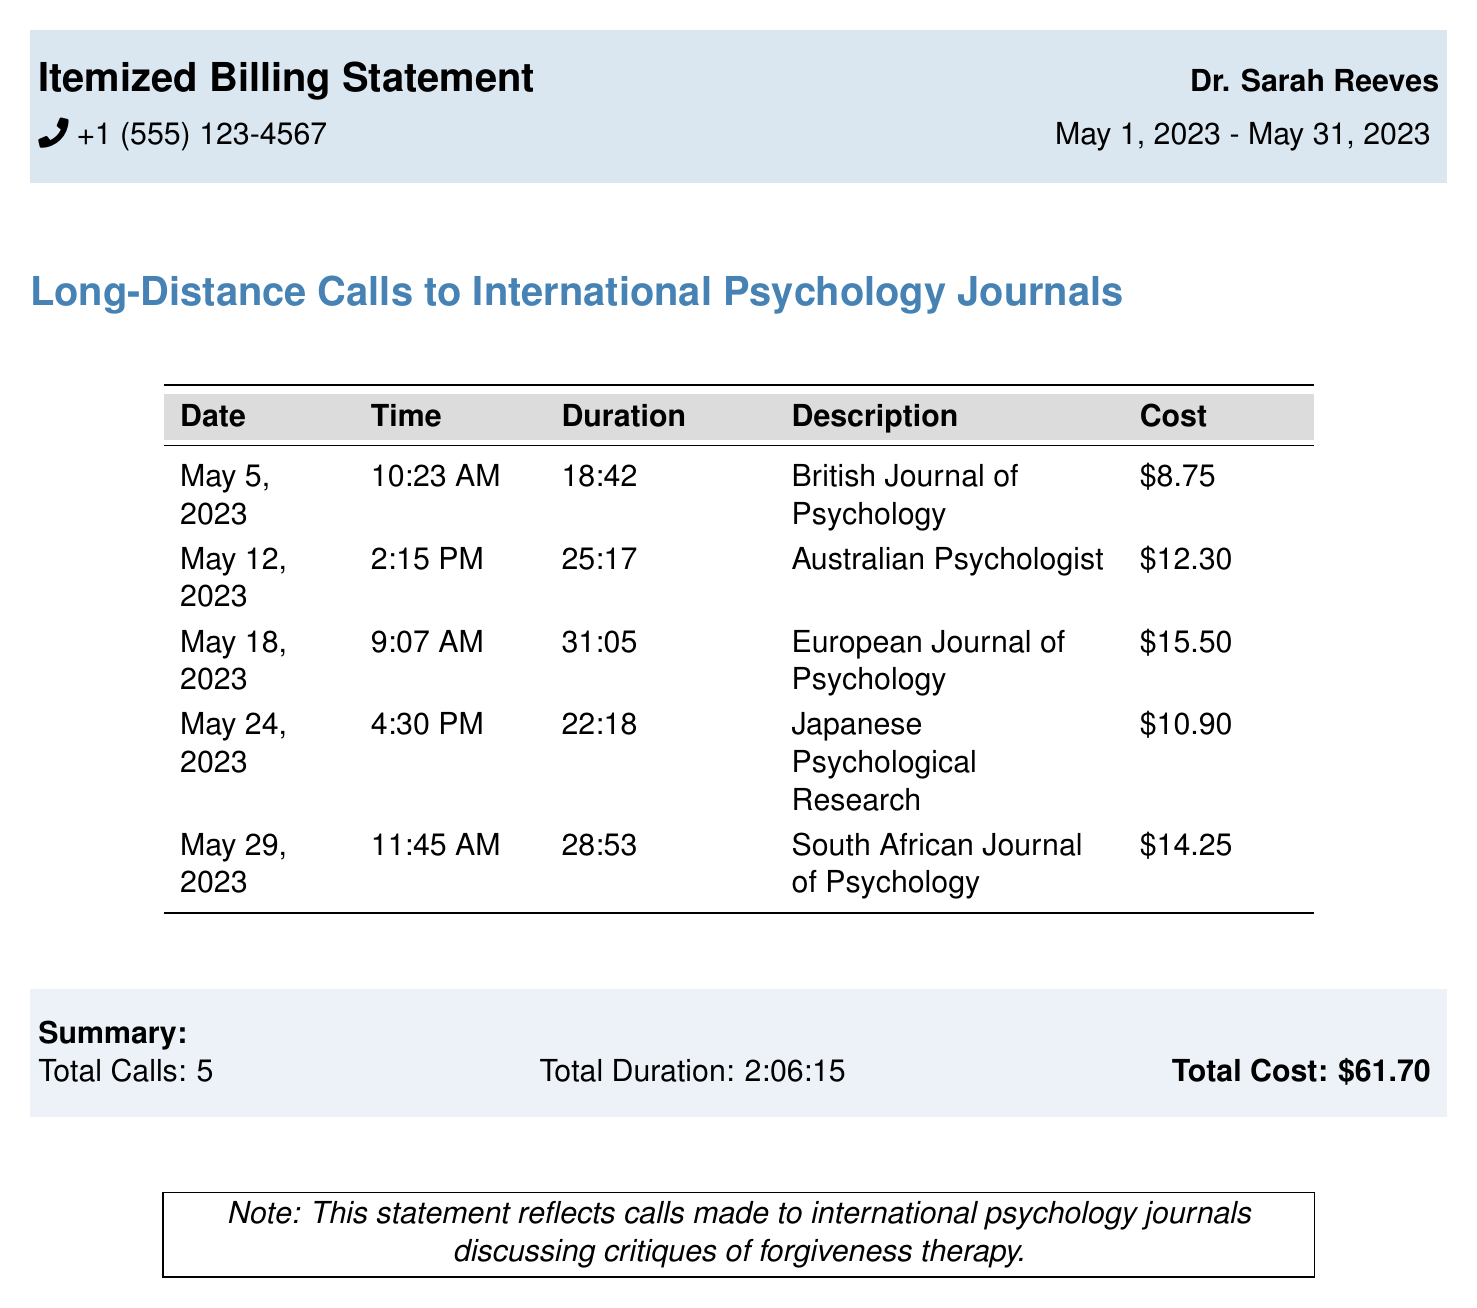what is the total cost of the calls? The total cost is a summary value at the end of the document, calculated by summing all individual call costs, which is $8.75 + $12.30 + $15.50 + $10.90 + $14.25.
Answer: $61.70 how many total calls were made? The total number of calls is specified in the summary section of the document.
Answer: 5 what was the duration of the longest call? The duration of the longest call can be found in the table; the call to the European Journal of Psychology has the longest duration of 31 minutes and 5 seconds.
Answer: 31:05 which journal was called on May 12, 2023? The journal called on this date is noted in the respective row of the table.
Answer: Australian Psychologist what was the cost of the call to the South African Journal of Psychology? The cost is listed in the table under the respective call entry.
Answer: $14.25 what is the time of the call made to the British Journal of Psychology? The time is explicitly mentioned in the same row as the call entry in the table.
Answer: 10:23 AM how much time was spent on the calls in total? The total duration is provided in the summary section, which adds up all individual call times.
Answer: 2:06:15 which call had the second highest cost? To determine this, one would compare the costs of all calls listed in the table.
Answer: Australian Psychologist what is the purpose of the calls made in this statement? The purpose is noted in the document as reflecting on critiques of a specific therapy approach.
Answer: Discussing critiques of forgiveness therapy 